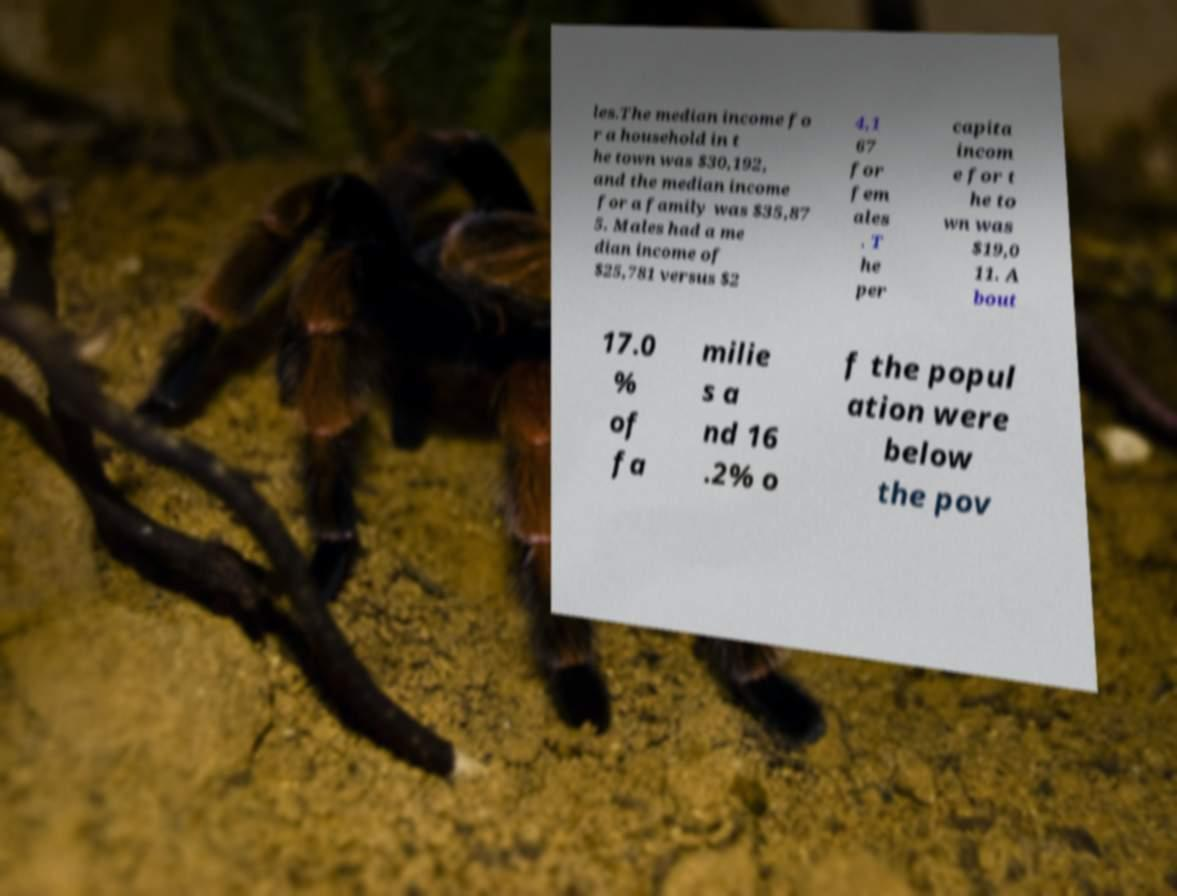Please identify and transcribe the text found in this image. les.The median income fo r a household in t he town was $30,192, and the median income for a family was $35,87 5. Males had a me dian income of $25,781 versus $2 4,1 67 for fem ales . T he per capita incom e for t he to wn was $19,0 11. A bout 17.0 % of fa milie s a nd 16 .2% o f the popul ation were below the pov 